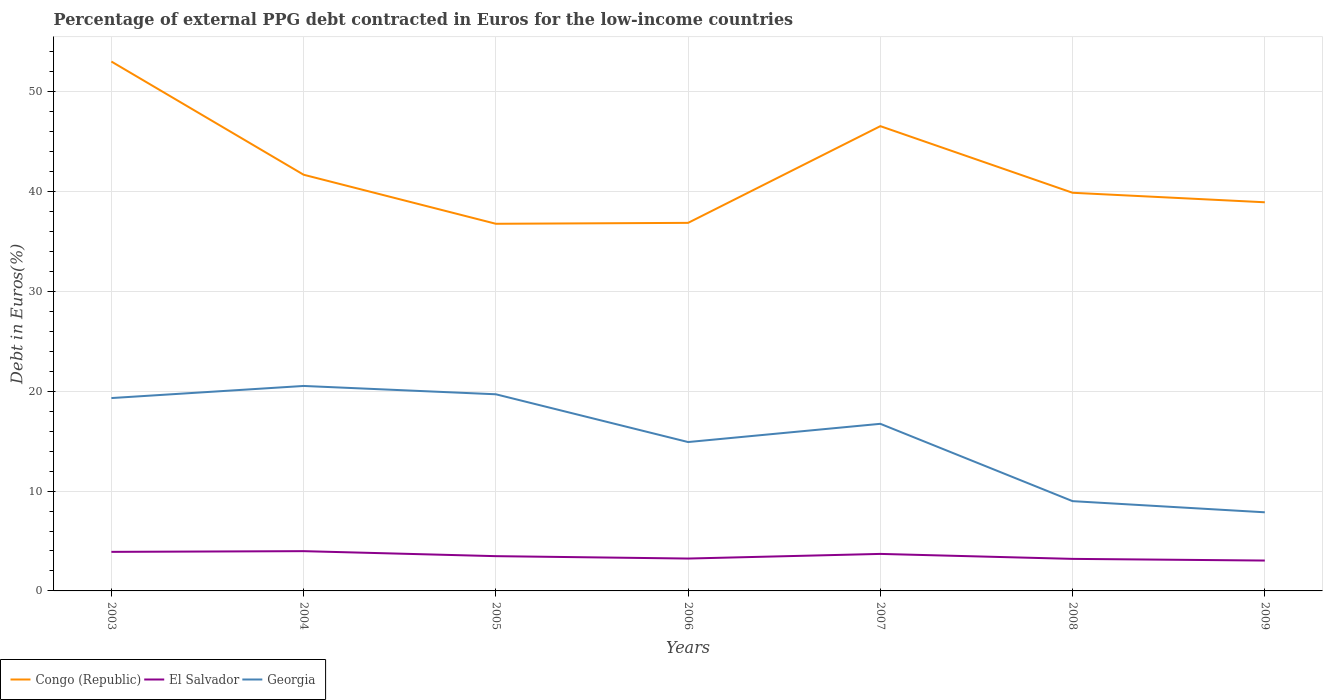How many different coloured lines are there?
Make the answer very short. 3. Does the line corresponding to Congo (Republic) intersect with the line corresponding to Georgia?
Offer a terse response. No. Is the number of lines equal to the number of legend labels?
Give a very brief answer. Yes. Across all years, what is the maximum percentage of external PPG debt contracted in Euros in Georgia?
Keep it short and to the point. 7.88. What is the total percentage of external PPG debt contracted in Euros in Georgia in the graph?
Your answer should be compact. 5.62. What is the difference between the highest and the second highest percentage of external PPG debt contracted in Euros in Congo (Republic)?
Your answer should be compact. 16.25. What is the difference between the highest and the lowest percentage of external PPG debt contracted in Euros in El Salvador?
Offer a very short reply. 3. Is the percentage of external PPG debt contracted in Euros in El Salvador strictly greater than the percentage of external PPG debt contracted in Euros in Georgia over the years?
Your answer should be very brief. Yes. How many years are there in the graph?
Keep it short and to the point. 7. What is the difference between two consecutive major ticks on the Y-axis?
Your response must be concise. 10. Are the values on the major ticks of Y-axis written in scientific E-notation?
Offer a very short reply. No. Where does the legend appear in the graph?
Provide a short and direct response. Bottom left. How many legend labels are there?
Give a very brief answer. 3. How are the legend labels stacked?
Offer a terse response. Horizontal. What is the title of the graph?
Make the answer very short. Percentage of external PPG debt contracted in Euros for the low-income countries. Does "Guam" appear as one of the legend labels in the graph?
Offer a very short reply. No. What is the label or title of the Y-axis?
Your answer should be compact. Debt in Euros(%). What is the Debt in Euros(%) of Congo (Republic) in 2003?
Give a very brief answer. 53.02. What is the Debt in Euros(%) of El Salvador in 2003?
Offer a terse response. 3.91. What is the Debt in Euros(%) of Georgia in 2003?
Your answer should be very brief. 19.32. What is the Debt in Euros(%) of Congo (Republic) in 2004?
Ensure brevity in your answer.  41.69. What is the Debt in Euros(%) in El Salvador in 2004?
Your answer should be compact. 3.98. What is the Debt in Euros(%) in Georgia in 2004?
Make the answer very short. 20.53. What is the Debt in Euros(%) of Congo (Republic) in 2005?
Keep it short and to the point. 36.77. What is the Debt in Euros(%) in El Salvador in 2005?
Make the answer very short. 3.48. What is the Debt in Euros(%) of Georgia in 2005?
Your response must be concise. 19.7. What is the Debt in Euros(%) of Congo (Republic) in 2006?
Your answer should be very brief. 36.87. What is the Debt in Euros(%) in El Salvador in 2006?
Your answer should be very brief. 3.24. What is the Debt in Euros(%) of Georgia in 2006?
Make the answer very short. 14.91. What is the Debt in Euros(%) of Congo (Republic) in 2007?
Offer a terse response. 46.55. What is the Debt in Euros(%) of El Salvador in 2007?
Provide a short and direct response. 3.71. What is the Debt in Euros(%) of Georgia in 2007?
Your response must be concise. 16.74. What is the Debt in Euros(%) in Congo (Republic) in 2008?
Make the answer very short. 39.88. What is the Debt in Euros(%) of El Salvador in 2008?
Offer a terse response. 3.21. What is the Debt in Euros(%) of Georgia in 2008?
Offer a terse response. 8.99. What is the Debt in Euros(%) of Congo (Republic) in 2009?
Give a very brief answer. 38.93. What is the Debt in Euros(%) in El Salvador in 2009?
Give a very brief answer. 3.04. What is the Debt in Euros(%) of Georgia in 2009?
Make the answer very short. 7.88. Across all years, what is the maximum Debt in Euros(%) in Congo (Republic)?
Keep it short and to the point. 53.02. Across all years, what is the maximum Debt in Euros(%) of El Salvador?
Make the answer very short. 3.98. Across all years, what is the maximum Debt in Euros(%) in Georgia?
Offer a terse response. 20.53. Across all years, what is the minimum Debt in Euros(%) in Congo (Republic)?
Keep it short and to the point. 36.77. Across all years, what is the minimum Debt in Euros(%) of El Salvador?
Provide a succinct answer. 3.04. Across all years, what is the minimum Debt in Euros(%) in Georgia?
Your answer should be very brief. 7.88. What is the total Debt in Euros(%) in Congo (Republic) in the graph?
Offer a very short reply. 293.7. What is the total Debt in Euros(%) in El Salvador in the graph?
Your answer should be compact. 24.58. What is the total Debt in Euros(%) of Georgia in the graph?
Provide a succinct answer. 108.06. What is the difference between the Debt in Euros(%) in Congo (Republic) in 2003 and that in 2004?
Your answer should be very brief. 11.34. What is the difference between the Debt in Euros(%) of El Salvador in 2003 and that in 2004?
Make the answer very short. -0.07. What is the difference between the Debt in Euros(%) in Georgia in 2003 and that in 2004?
Keep it short and to the point. -1.21. What is the difference between the Debt in Euros(%) in Congo (Republic) in 2003 and that in 2005?
Provide a short and direct response. 16.25. What is the difference between the Debt in Euros(%) in El Salvador in 2003 and that in 2005?
Keep it short and to the point. 0.43. What is the difference between the Debt in Euros(%) of Georgia in 2003 and that in 2005?
Provide a short and direct response. -0.38. What is the difference between the Debt in Euros(%) in Congo (Republic) in 2003 and that in 2006?
Provide a short and direct response. 16.16. What is the difference between the Debt in Euros(%) in El Salvador in 2003 and that in 2006?
Offer a terse response. 0.67. What is the difference between the Debt in Euros(%) of Georgia in 2003 and that in 2006?
Your answer should be compact. 4.4. What is the difference between the Debt in Euros(%) in Congo (Republic) in 2003 and that in 2007?
Your answer should be compact. 6.47. What is the difference between the Debt in Euros(%) of El Salvador in 2003 and that in 2007?
Offer a terse response. 0.21. What is the difference between the Debt in Euros(%) in Georgia in 2003 and that in 2007?
Ensure brevity in your answer.  2.58. What is the difference between the Debt in Euros(%) of Congo (Republic) in 2003 and that in 2008?
Make the answer very short. 13.15. What is the difference between the Debt in Euros(%) of El Salvador in 2003 and that in 2008?
Keep it short and to the point. 0.7. What is the difference between the Debt in Euros(%) of Georgia in 2003 and that in 2008?
Give a very brief answer. 10.32. What is the difference between the Debt in Euros(%) of Congo (Republic) in 2003 and that in 2009?
Provide a short and direct response. 14.1. What is the difference between the Debt in Euros(%) in El Salvador in 2003 and that in 2009?
Provide a succinct answer. 0.87. What is the difference between the Debt in Euros(%) of Georgia in 2003 and that in 2009?
Offer a terse response. 11.44. What is the difference between the Debt in Euros(%) in Congo (Republic) in 2004 and that in 2005?
Make the answer very short. 4.91. What is the difference between the Debt in Euros(%) in El Salvador in 2004 and that in 2005?
Offer a very short reply. 0.5. What is the difference between the Debt in Euros(%) of Georgia in 2004 and that in 2005?
Provide a short and direct response. 0.83. What is the difference between the Debt in Euros(%) of Congo (Republic) in 2004 and that in 2006?
Your answer should be very brief. 4.82. What is the difference between the Debt in Euros(%) in El Salvador in 2004 and that in 2006?
Offer a terse response. 0.74. What is the difference between the Debt in Euros(%) of Georgia in 2004 and that in 2006?
Give a very brief answer. 5.62. What is the difference between the Debt in Euros(%) in Congo (Republic) in 2004 and that in 2007?
Provide a short and direct response. -4.87. What is the difference between the Debt in Euros(%) of El Salvador in 2004 and that in 2007?
Your answer should be compact. 0.28. What is the difference between the Debt in Euros(%) of Georgia in 2004 and that in 2007?
Offer a terse response. 3.79. What is the difference between the Debt in Euros(%) in Congo (Republic) in 2004 and that in 2008?
Provide a succinct answer. 1.81. What is the difference between the Debt in Euros(%) of El Salvador in 2004 and that in 2008?
Make the answer very short. 0.77. What is the difference between the Debt in Euros(%) in Georgia in 2004 and that in 2008?
Offer a very short reply. 11.54. What is the difference between the Debt in Euros(%) in Congo (Republic) in 2004 and that in 2009?
Your response must be concise. 2.76. What is the difference between the Debt in Euros(%) in El Salvador in 2004 and that in 2009?
Your answer should be compact. 0.94. What is the difference between the Debt in Euros(%) of Georgia in 2004 and that in 2009?
Keep it short and to the point. 12.65. What is the difference between the Debt in Euros(%) of Congo (Republic) in 2005 and that in 2006?
Your answer should be compact. -0.09. What is the difference between the Debt in Euros(%) of El Salvador in 2005 and that in 2006?
Give a very brief answer. 0.24. What is the difference between the Debt in Euros(%) of Georgia in 2005 and that in 2006?
Offer a terse response. 4.78. What is the difference between the Debt in Euros(%) of Congo (Republic) in 2005 and that in 2007?
Offer a very short reply. -9.78. What is the difference between the Debt in Euros(%) of El Salvador in 2005 and that in 2007?
Ensure brevity in your answer.  -0.23. What is the difference between the Debt in Euros(%) in Georgia in 2005 and that in 2007?
Your answer should be very brief. 2.96. What is the difference between the Debt in Euros(%) of Congo (Republic) in 2005 and that in 2008?
Give a very brief answer. -3.11. What is the difference between the Debt in Euros(%) of El Salvador in 2005 and that in 2008?
Make the answer very short. 0.27. What is the difference between the Debt in Euros(%) in Georgia in 2005 and that in 2008?
Your answer should be compact. 10.7. What is the difference between the Debt in Euros(%) in Congo (Republic) in 2005 and that in 2009?
Provide a succinct answer. -2.15. What is the difference between the Debt in Euros(%) of El Salvador in 2005 and that in 2009?
Your response must be concise. 0.44. What is the difference between the Debt in Euros(%) of Georgia in 2005 and that in 2009?
Make the answer very short. 11.82. What is the difference between the Debt in Euros(%) of Congo (Republic) in 2006 and that in 2007?
Your answer should be very brief. -9.69. What is the difference between the Debt in Euros(%) of El Salvador in 2006 and that in 2007?
Offer a very short reply. -0.46. What is the difference between the Debt in Euros(%) in Georgia in 2006 and that in 2007?
Give a very brief answer. -1.83. What is the difference between the Debt in Euros(%) in Congo (Republic) in 2006 and that in 2008?
Make the answer very short. -3.01. What is the difference between the Debt in Euros(%) in El Salvador in 2006 and that in 2008?
Offer a very short reply. 0.03. What is the difference between the Debt in Euros(%) in Georgia in 2006 and that in 2008?
Provide a succinct answer. 5.92. What is the difference between the Debt in Euros(%) of Congo (Republic) in 2006 and that in 2009?
Provide a short and direct response. -2.06. What is the difference between the Debt in Euros(%) of El Salvador in 2006 and that in 2009?
Make the answer very short. 0.2. What is the difference between the Debt in Euros(%) in Georgia in 2006 and that in 2009?
Your answer should be compact. 7.04. What is the difference between the Debt in Euros(%) in Congo (Republic) in 2007 and that in 2008?
Your response must be concise. 6.67. What is the difference between the Debt in Euros(%) in El Salvador in 2007 and that in 2008?
Your response must be concise. 0.5. What is the difference between the Debt in Euros(%) of Georgia in 2007 and that in 2008?
Your answer should be very brief. 7.75. What is the difference between the Debt in Euros(%) of Congo (Republic) in 2007 and that in 2009?
Keep it short and to the point. 7.62. What is the difference between the Debt in Euros(%) of El Salvador in 2007 and that in 2009?
Keep it short and to the point. 0.66. What is the difference between the Debt in Euros(%) of Georgia in 2007 and that in 2009?
Keep it short and to the point. 8.86. What is the difference between the Debt in Euros(%) in Congo (Republic) in 2008 and that in 2009?
Keep it short and to the point. 0.95. What is the difference between the Debt in Euros(%) in El Salvador in 2008 and that in 2009?
Your answer should be compact. 0.17. What is the difference between the Debt in Euros(%) in Georgia in 2008 and that in 2009?
Make the answer very short. 1.12. What is the difference between the Debt in Euros(%) of Congo (Republic) in 2003 and the Debt in Euros(%) of El Salvador in 2004?
Offer a very short reply. 49.04. What is the difference between the Debt in Euros(%) of Congo (Republic) in 2003 and the Debt in Euros(%) of Georgia in 2004?
Your answer should be compact. 32.49. What is the difference between the Debt in Euros(%) of El Salvador in 2003 and the Debt in Euros(%) of Georgia in 2004?
Your answer should be compact. -16.62. What is the difference between the Debt in Euros(%) in Congo (Republic) in 2003 and the Debt in Euros(%) in El Salvador in 2005?
Give a very brief answer. 49.54. What is the difference between the Debt in Euros(%) in Congo (Republic) in 2003 and the Debt in Euros(%) in Georgia in 2005?
Keep it short and to the point. 33.33. What is the difference between the Debt in Euros(%) in El Salvador in 2003 and the Debt in Euros(%) in Georgia in 2005?
Provide a short and direct response. -15.78. What is the difference between the Debt in Euros(%) in Congo (Republic) in 2003 and the Debt in Euros(%) in El Salvador in 2006?
Your answer should be very brief. 49.78. What is the difference between the Debt in Euros(%) in Congo (Republic) in 2003 and the Debt in Euros(%) in Georgia in 2006?
Your answer should be very brief. 38.11. What is the difference between the Debt in Euros(%) in El Salvador in 2003 and the Debt in Euros(%) in Georgia in 2006?
Your answer should be very brief. -11. What is the difference between the Debt in Euros(%) in Congo (Republic) in 2003 and the Debt in Euros(%) in El Salvador in 2007?
Give a very brief answer. 49.32. What is the difference between the Debt in Euros(%) of Congo (Republic) in 2003 and the Debt in Euros(%) of Georgia in 2007?
Give a very brief answer. 36.29. What is the difference between the Debt in Euros(%) in El Salvador in 2003 and the Debt in Euros(%) in Georgia in 2007?
Keep it short and to the point. -12.83. What is the difference between the Debt in Euros(%) in Congo (Republic) in 2003 and the Debt in Euros(%) in El Salvador in 2008?
Make the answer very short. 49.81. What is the difference between the Debt in Euros(%) of Congo (Republic) in 2003 and the Debt in Euros(%) of Georgia in 2008?
Your answer should be very brief. 44.03. What is the difference between the Debt in Euros(%) of El Salvador in 2003 and the Debt in Euros(%) of Georgia in 2008?
Ensure brevity in your answer.  -5.08. What is the difference between the Debt in Euros(%) in Congo (Republic) in 2003 and the Debt in Euros(%) in El Salvador in 2009?
Offer a very short reply. 49.98. What is the difference between the Debt in Euros(%) of Congo (Republic) in 2003 and the Debt in Euros(%) of Georgia in 2009?
Your answer should be very brief. 45.15. What is the difference between the Debt in Euros(%) in El Salvador in 2003 and the Debt in Euros(%) in Georgia in 2009?
Keep it short and to the point. -3.96. What is the difference between the Debt in Euros(%) of Congo (Republic) in 2004 and the Debt in Euros(%) of El Salvador in 2005?
Make the answer very short. 38.2. What is the difference between the Debt in Euros(%) of Congo (Republic) in 2004 and the Debt in Euros(%) of Georgia in 2005?
Offer a terse response. 21.99. What is the difference between the Debt in Euros(%) of El Salvador in 2004 and the Debt in Euros(%) of Georgia in 2005?
Your answer should be compact. -15.71. What is the difference between the Debt in Euros(%) of Congo (Republic) in 2004 and the Debt in Euros(%) of El Salvador in 2006?
Offer a very short reply. 38.44. What is the difference between the Debt in Euros(%) of Congo (Republic) in 2004 and the Debt in Euros(%) of Georgia in 2006?
Your answer should be compact. 26.77. What is the difference between the Debt in Euros(%) of El Salvador in 2004 and the Debt in Euros(%) of Georgia in 2006?
Offer a very short reply. -10.93. What is the difference between the Debt in Euros(%) of Congo (Republic) in 2004 and the Debt in Euros(%) of El Salvador in 2007?
Offer a terse response. 37.98. What is the difference between the Debt in Euros(%) in Congo (Republic) in 2004 and the Debt in Euros(%) in Georgia in 2007?
Give a very brief answer. 24.95. What is the difference between the Debt in Euros(%) in El Salvador in 2004 and the Debt in Euros(%) in Georgia in 2007?
Provide a short and direct response. -12.76. What is the difference between the Debt in Euros(%) of Congo (Republic) in 2004 and the Debt in Euros(%) of El Salvador in 2008?
Provide a succinct answer. 38.48. What is the difference between the Debt in Euros(%) of Congo (Republic) in 2004 and the Debt in Euros(%) of Georgia in 2008?
Your answer should be very brief. 32.69. What is the difference between the Debt in Euros(%) in El Salvador in 2004 and the Debt in Euros(%) in Georgia in 2008?
Ensure brevity in your answer.  -5.01. What is the difference between the Debt in Euros(%) of Congo (Republic) in 2004 and the Debt in Euros(%) of El Salvador in 2009?
Make the answer very short. 38.64. What is the difference between the Debt in Euros(%) in Congo (Republic) in 2004 and the Debt in Euros(%) in Georgia in 2009?
Make the answer very short. 33.81. What is the difference between the Debt in Euros(%) of El Salvador in 2004 and the Debt in Euros(%) of Georgia in 2009?
Your response must be concise. -3.89. What is the difference between the Debt in Euros(%) of Congo (Republic) in 2005 and the Debt in Euros(%) of El Salvador in 2006?
Give a very brief answer. 33.53. What is the difference between the Debt in Euros(%) of Congo (Republic) in 2005 and the Debt in Euros(%) of Georgia in 2006?
Give a very brief answer. 21.86. What is the difference between the Debt in Euros(%) of El Salvador in 2005 and the Debt in Euros(%) of Georgia in 2006?
Offer a terse response. -11.43. What is the difference between the Debt in Euros(%) in Congo (Republic) in 2005 and the Debt in Euros(%) in El Salvador in 2007?
Ensure brevity in your answer.  33.07. What is the difference between the Debt in Euros(%) of Congo (Republic) in 2005 and the Debt in Euros(%) of Georgia in 2007?
Your answer should be compact. 20.03. What is the difference between the Debt in Euros(%) in El Salvador in 2005 and the Debt in Euros(%) in Georgia in 2007?
Offer a very short reply. -13.26. What is the difference between the Debt in Euros(%) of Congo (Republic) in 2005 and the Debt in Euros(%) of El Salvador in 2008?
Make the answer very short. 33.56. What is the difference between the Debt in Euros(%) of Congo (Republic) in 2005 and the Debt in Euros(%) of Georgia in 2008?
Ensure brevity in your answer.  27.78. What is the difference between the Debt in Euros(%) in El Salvador in 2005 and the Debt in Euros(%) in Georgia in 2008?
Offer a very short reply. -5.51. What is the difference between the Debt in Euros(%) in Congo (Republic) in 2005 and the Debt in Euros(%) in El Salvador in 2009?
Provide a succinct answer. 33.73. What is the difference between the Debt in Euros(%) in Congo (Republic) in 2005 and the Debt in Euros(%) in Georgia in 2009?
Ensure brevity in your answer.  28.9. What is the difference between the Debt in Euros(%) in El Salvador in 2005 and the Debt in Euros(%) in Georgia in 2009?
Your answer should be very brief. -4.39. What is the difference between the Debt in Euros(%) in Congo (Republic) in 2006 and the Debt in Euros(%) in El Salvador in 2007?
Provide a succinct answer. 33.16. What is the difference between the Debt in Euros(%) in Congo (Republic) in 2006 and the Debt in Euros(%) in Georgia in 2007?
Ensure brevity in your answer.  20.13. What is the difference between the Debt in Euros(%) in El Salvador in 2006 and the Debt in Euros(%) in Georgia in 2007?
Your response must be concise. -13.49. What is the difference between the Debt in Euros(%) in Congo (Republic) in 2006 and the Debt in Euros(%) in El Salvador in 2008?
Offer a terse response. 33.66. What is the difference between the Debt in Euros(%) in Congo (Republic) in 2006 and the Debt in Euros(%) in Georgia in 2008?
Your answer should be very brief. 27.87. What is the difference between the Debt in Euros(%) in El Salvador in 2006 and the Debt in Euros(%) in Georgia in 2008?
Give a very brief answer. -5.75. What is the difference between the Debt in Euros(%) of Congo (Republic) in 2006 and the Debt in Euros(%) of El Salvador in 2009?
Provide a short and direct response. 33.82. What is the difference between the Debt in Euros(%) in Congo (Republic) in 2006 and the Debt in Euros(%) in Georgia in 2009?
Give a very brief answer. 28.99. What is the difference between the Debt in Euros(%) in El Salvador in 2006 and the Debt in Euros(%) in Georgia in 2009?
Offer a very short reply. -4.63. What is the difference between the Debt in Euros(%) in Congo (Republic) in 2007 and the Debt in Euros(%) in El Salvador in 2008?
Offer a terse response. 43.34. What is the difference between the Debt in Euros(%) of Congo (Republic) in 2007 and the Debt in Euros(%) of Georgia in 2008?
Your answer should be compact. 37.56. What is the difference between the Debt in Euros(%) in El Salvador in 2007 and the Debt in Euros(%) in Georgia in 2008?
Give a very brief answer. -5.29. What is the difference between the Debt in Euros(%) in Congo (Republic) in 2007 and the Debt in Euros(%) in El Salvador in 2009?
Provide a short and direct response. 43.51. What is the difference between the Debt in Euros(%) of Congo (Republic) in 2007 and the Debt in Euros(%) of Georgia in 2009?
Your answer should be very brief. 38.68. What is the difference between the Debt in Euros(%) in El Salvador in 2007 and the Debt in Euros(%) in Georgia in 2009?
Ensure brevity in your answer.  -4.17. What is the difference between the Debt in Euros(%) in Congo (Republic) in 2008 and the Debt in Euros(%) in El Salvador in 2009?
Keep it short and to the point. 36.84. What is the difference between the Debt in Euros(%) in Congo (Republic) in 2008 and the Debt in Euros(%) in Georgia in 2009?
Make the answer very short. 32. What is the difference between the Debt in Euros(%) of El Salvador in 2008 and the Debt in Euros(%) of Georgia in 2009?
Ensure brevity in your answer.  -4.67. What is the average Debt in Euros(%) in Congo (Republic) per year?
Make the answer very short. 41.96. What is the average Debt in Euros(%) of El Salvador per year?
Your response must be concise. 3.51. What is the average Debt in Euros(%) in Georgia per year?
Keep it short and to the point. 15.44. In the year 2003, what is the difference between the Debt in Euros(%) of Congo (Republic) and Debt in Euros(%) of El Salvador?
Make the answer very short. 49.11. In the year 2003, what is the difference between the Debt in Euros(%) in Congo (Republic) and Debt in Euros(%) in Georgia?
Keep it short and to the point. 33.71. In the year 2003, what is the difference between the Debt in Euros(%) in El Salvador and Debt in Euros(%) in Georgia?
Give a very brief answer. -15.4. In the year 2004, what is the difference between the Debt in Euros(%) in Congo (Republic) and Debt in Euros(%) in El Salvador?
Give a very brief answer. 37.7. In the year 2004, what is the difference between the Debt in Euros(%) of Congo (Republic) and Debt in Euros(%) of Georgia?
Offer a very short reply. 21.15. In the year 2004, what is the difference between the Debt in Euros(%) of El Salvador and Debt in Euros(%) of Georgia?
Provide a succinct answer. -16.55. In the year 2005, what is the difference between the Debt in Euros(%) in Congo (Republic) and Debt in Euros(%) in El Salvador?
Your answer should be very brief. 33.29. In the year 2005, what is the difference between the Debt in Euros(%) of Congo (Republic) and Debt in Euros(%) of Georgia?
Your answer should be very brief. 17.08. In the year 2005, what is the difference between the Debt in Euros(%) of El Salvador and Debt in Euros(%) of Georgia?
Ensure brevity in your answer.  -16.21. In the year 2006, what is the difference between the Debt in Euros(%) in Congo (Republic) and Debt in Euros(%) in El Salvador?
Offer a very short reply. 33.62. In the year 2006, what is the difference between the Debt in Euros(%) in Congo (Republic) and Debt in Euros(%) in Georgia?
Ensure brevity in your answer.  21.95. In the year 2006, what is the difference between the Debt in Euros(%) in El Salvador and Debt in Euros(%) in Georgia?
Make the answer very short. -11.67. In the year 2007, what is the difference between the Debt in Euros(%) of Congo (Republic) and Debt in Euros(%) of El Salvador?
Make the answer very short. 42.84. In the year 2007, what is the difference between the Debt in Euros(%) of Congo (Republic) and Debt in Euros(%) of Georgia?
Offer a very short reply. 29.81. In the year 2007, what is the difference between the Debt in Euros(%) in El Salvador and Debt in Euros(%) in Georgia?
Your answer should be very brief. -13.03. In the year 2008, what is the difference between the Debt in Euros(%) of Congo (Republic) and Debt in Euros(%) of El Salvador?
Ensure brevity in your answer.  36.67. In the year 2008, what is the difference between the Debt in Euros(%) of Congo (Republic) and Debt in Euros(%) of Georgia?
Your response must be concise. 30.89. In the year 2008, what is the difference between the Debt in Euros(%) in El Salvador and Debt in Euros(%) in Georgia?
Ensure brevity in your answer.  -5.78. In the year 2009, what is the difference between the Debt in Euros(%) in Congo (Republic) and Debt in Euros(%) in El Salvador?
Offer a terse response. 35.88. In the year 2009, what is the difference between the Debt in Euros(%) of Congo (Republic) and Debt in Euros(%) of Georgia?
Offer a terse response. 31.05. In the year 2009, what is the difference between the Debt in Euros(%) in El Salvador and Debt in Euros(%) in Georgia?
Your response must be concise. -4.83. What is the ratio of the Debt in Euros(%) of Congo (Republic) in 2003 to that in 2004?
Your answer should be very brief. 1.27. What is the ratio of the Debt in Euros(%) in El Salvador in 2003 to that in 2004?
Keep it short and to the point. 0.98. What is the ratio of the Debt in Euros(%) of Georgia in 2003 to that in 2004?
Make the answer very short. 0.94. What is the ratio of the Debt in Euros(%) in Congo (Republic) in 2003 to that in 2005?
Your response must be concise. 1.44. What is the ratio of the Debt in Euros(%) in El Salvador in 2003 to that in 2005?
Your response must be concise. 1.12. What is the ratio of the Debt in Euros(%) of Georgia in 2003 to that in 2005?
Keep it short and to the point. 0.98. What is the ratio of the Debt in Euros(%) of Congo (Republic) in 2003 to that in 2006?
Your answer should be compact. 1.44. What is the ratio of the Debt in Euros(%) in El Salvador in 2003 to that in 2006?
Offer a terse response. 1.21. What is the ratio of the Debt in Euros(%) of Georgia in 2003 to that in 2006?
Give a very brief answer. 1.3. What is the ratio of the Debt in Euros(%) of Congo (Republic) in 2003 to that in 2007?
Provide a short and direct response. 1.14. What is the ratio of the Debt in Euros(%) in El Salvador in 2003 to that in 2007?
Ensure brevity in your answer.  1.06. What is the ratio of the Debt in Euros(%) in Georgia in 2003 to that in 2007?
Make the answer very short. 1.15. What is the ratio of the Debt in Euros(%) in Congo (Republic) in 2003 to that in 2008?
Make the answer very short. 1.33. What is the ratio of the Debt in Euros(%) in El Salvador in 2003 to that in 2008?
Make the answer very short. 1.22. What is the ratio of the Debt in Euros(%) in Georgia in 2003 to that in 2008?
Your answer should be very brief. 2.15. What is the ratio of the Debt in Euros(%) in Congo (Republic) in 2003 to that in 2009?
Keep it short and to the point. 1.36. What is the ratio of the Debt in Euros(%) in El Salvador in 2003 to that in 2009?
Provide a short and direct response. 1.29. What is the ratio of the Debt in Euros(%) of Georgia in 2003 to that in 2009?
Provide a succinct answer. 2.45. What is the ratio of the Debt in Euros(%) of Congo (Republic) in 2004 to that in 2005?
Offer a very short reply. 1.13. What is the ratio of the Debt in Euros(%) of El Salvador in 2004 to that in 2005?
Keep it short and to the point. 1.14. What is the ratio of the Debt in Euros(%) of Georgia in 2004 to that in 2005?
Make the answer very short. 1.04. What is the ratio of the Debt in Euros(%) in Congo (Republic) in 2004 to that in 2006?
Ensure brevity in your answer.  1.13. What is the ratio of the Debt in Euros(%) of El Salvador in 2004 to that in 2006?
Give a very brief answer. 1.23. What is the ratio of the Debt in Euros(%) of Georgia in 2004 to that in 2006?
Your answer should be compact. 1.38. What is the ratio of the Debt in Euros(%) in Congo (Republic) in 2004 to that in 2007?
Offer a very short reply. 0.9. What is the ratio of the Debt in Euros(%) of El Salvador in 2004 to that in 2007?
Make the answer very short. 1.07. What is the ratio of the Debt in Euros(%) in Georgia in 2004 to that in 2007?
Give a very brief answer. 1.23. What is the ratio of the Debt in Euros(%) of Congo (Republic) in 2004 to that in 2008?
Offer a very short reply. 1.05. What is the ratio of the Debt in Euros(%) of El Salvador in 2004 to that in 2008?
Offer a very short reply. 1.24. What is the ratio of the Debt in Euros(%) in Georgia in 2004 to that in 2008?
Keep it short and to the point. 2.28. What is the ratio of the Debt in Euros(%) of Congo (Republic) in 2004 to that in 2009?
Offer a very short reply. 1.07. What is the ratio of the Debt in Euros(%) in El Salvador in 2004 to that in 2009?
Give a very brief answer. 1.31. What is the ratio of the Debt in Euros(%) of Georgia in 2004 to that in 2009?
Give a very brief answer. 2.61. What is the ratio of the Debt in Euros(%) in Congo (Republic) in 2005 to that in 2006?
Provide a short and direct response. 1. What is the ratio of the Debt in Euros(%) in El Salvador in 2005 to that in 2006?
Keep it short and to the point. 1.07. What is the ratio of the Debt in Euros(%) of Georgia in 2005 to that in 2006?
Provide a short and direct response. 1.32. What is the ratio of the Debt in Euros(%) in Congo (Republic) in 2005 to that in 2007?
Provide a succinct answer. 0.79. What is the ratio of the Debt in Euros(%) in El Salvador in 2005 to that in 2007?
Your answer should be compact. 0.94. What is the ratio of the Debt in Euros(%) of Georgia in 2005 to that in 2007?
Your answer should be very brief. 1.18. What is the ratio of the Debt in Euros(%) in Congo (Republic) in 2005 to that in 2008?
Your answer should be very brief. 0.92. What is the ratio of the Debt in Euros(%) of El Salvador in 2005 to that in 2008?
Give a very brief answer. 1.08. What is the ratio of the Debt in Euros(%) in Georgia in 2005 to that in 2008?
Keep it short and to the point. 2.19. What is the ratio of the Debt in Euros(%) in Congo (Republic) in 2005 to that in 2009?
Your answer should be compact. 0.94. What is the ratio of the Debt in Euros(%) in El Salvador in 2005 to that in 2009?
Provide a short and direct response. 1.14. What is the ratio of the Debt in Euros(%) of Georgia in 2005 to that in 2009?
Offer a terse response. 2.5. What is the ratio of the Debt in Euros(%) of Congo (Republic) in 2006 to that in 2007?
Provide a short and direct response. 0.79. What is the ratio of the Debt in Euros(%) in El Salvador in 2006 to that in 2007?
Your answer should be very brief. 0.87. What is the ratio of the Debt in Euros(%) in Georgia in 2006 to that in 2007?
Offer a terse response. 0.89. What is the ratio of the Debt in Euros(%) in Congo (Republic) in 2006 to that in 2008?
Offer a terse response. 0.92. What is the ratio of the Debt in Euros(%) of El Salvador in 2006 to that in 2008?
Your answer should be very brief. 1.01. What is the ratio of the Debt in Euros(%) in Georgia in 2006 to that in 2008?
Keep it short and to the point. 1.66. What is the ratio of the Debt in Euros(%) in Congo (Republic) in 2006 to that in 2009?
Give a very brief answer. 0.95. What is the ratio of the Debt in Euros(%) in El Salvador in 2006 to that in 2009?
Provide a succinct answer. 1.07. What is the ratio of the Debt in Euros(%) in Georgia in 2006 to that in 2009?
Provide a short and direct response. 1.89. What is the ratio of the Debt in Euros(%) in Congo (Republic) in 2007 to that in 2008?
Provide a succinct answer. 1.17. What is the ratio of the Debt in Euros(%) in El Salvador in 2007 to that in 2008?
Keep it short and to the point. 1.15. What is the ratio of the Debt in Euros(%) in Georgia in 2007 to that in 2008?
Your response must be concise. 1.86. What is the ratio of the Debt in Euros(%) of Congo (Republic) in 2007 to that in 2009?
Make the answer very short. 1.2. What is the ratio of the Debt in Euros(%) of El Salvador in 2007 to that in 2009?
Your response must be concise. 1.22. What is the ratio of the Debt in Euros(%) in Georgia in 2007 to that in 2009?
Keep it short and to the point. 2.13. What is the ratio of the Debt in Euros(%) in Congo (Republic) in 2008 to that in 2009?
Your answer should be compact. 1.02. What is the ratio of the Debt in Euros(%) of El Salvador in 2008 to that in 2009?
Make the answer very short. 1.05. What is the ratio of the Debt in Euros(%) of Georgia in 2008 to that in 2009?
Offer a very short reply. 1.14. What is the difference between the highest and the second highest Debt in Euros(%) of Congo (Republic)?
Give a very brief answer. 6.47. What is the difference between the highest and the second highest Debt in Euros(%) in El Salvador?
Provide a short and direct response. 0.07. What is the difference between the highest and the second highest Debt in Euros(%) of Georgia?
Give a very brief answer. 0.83. What is the difference between the highest and the lowest Debt in Euros(%) in Congo (Republic)?
Keep it short and to the point. 16.25. What is the difference between the highest and the lowest Debt in Euros(%) in El Salvador?
Your answer should be very brief. 0.94. What is the difference between the highest and the lowest Debt in Euros(%) of Georgia?
Ensure brevity in your answer.  12.65. 